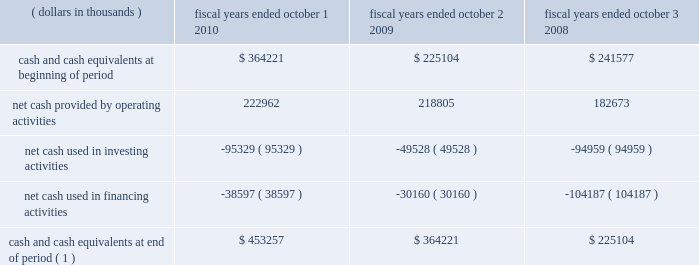31mar201122064257 positions which were required to be capitalized .
There are no positions which we anticipate could change materially within the next twelve months .
Liquidity and capital resources .
( 1 ) does not include restricted cash balances cash flow from operating activities : cash provided from operating activities is net income adjusted for certain non-cash items and changes in certain assets and liabilities .
For fiscal year 2010 we generated $ 223.0 million in cash flow from operations , an increase of $ 4.2 million when compared to the $ 218.8 million generated in fiscal year 2009 .
During fiscal year 2010 , net income increased by $ 42.3 million to $ 137.3 million when compared to fiscal year 2009 .
Despite the increase in net income , net cash provided by operating activities remained relatively consistent .
This was primarily due to : 2022 fiscal year 2010 net income included a deferred tax expense of $ 38.5 million compared to a $ 24.9 million deferred tax benefit included in 2009 net income due to the release of the tax valuation allowance in fiscal year 2009 .
2022 during fiscal year 2010 , the company invested in working capital as result of higher business activity .
Compared to fiscal year 2009 , accounts receivable , inventory and accounts payable increased by $ 60.9 million , $ 38.8 million and $ 42.9 million , respectively .
Cash flow from investing activities : cash flow from investing activities consists primarily of capital expenditures and acquisitions .
We had net cash outflows of $ 95.3 million in fiscal year 2010 , compared to $ 49.5 million in fiscal year 2009 .
The increase is primarily due to an increase of $ 49.8 million in capital expenditures .
We anticipate our capital spending to be consistent in fiscal year 2011 to maintain our projected growth rate .
Cash flow from financing activities : cash flows from financing activities consist primarily of cash transactions related to debt and equity .
During fiscal year 2010 , we had net cash outflows of $ 38.6 million , compared to $ 30.2 million in fiscal year 2009 .
During the year we had the following significant transactions : 2022 we retired $ 53.0 million in aggregate principal amount ( carrying value of $ 51.1 million ) of 2007 convertible notes for $ 80.7 million , which included a $ 29.6 million premium paid for the equity component of the instrument .
2022 we received net proceeds from employee stock option exercises of $ 40.5 million in fiscal year 2010 , compared to $ 38.7 million in fiscal year 2009 .
Skyworks / 2010 annual report 103 .
What is the percent increase in cash and cash equivalents from year 2009 to 2010? 
Computations: ((453257 - 364221) / 364221)
Answer: 0.24446. 31mar201122064257 positions which were required to be capitalized .
There are no positions which we anticipate could change materially within the next twelve months .
Liquidity and capital resources .
( 1 ) does not include restricted cash balances cash flow from operating activities : cash provided from operating activities is net income adjusted for certain non-cash items and changes in certain assets and liabilities .
For fiscal year 2010 we generated $ 223.0 million in cash flow from operations , an increase of $ 4.2 million when compared to the $ 218.8 million generated in fiscal year 2009 .
During fiscal year 2010 , net income increased by $ 42.3 million to $ 137.3 million when compared to fiscal year 2009 .
Despite the increase in net income , net cash provided by operating activities remained relatively consistent .
This was primarily due to : 2022 fiscal year 2010 net income included a deferred tax expense of $ 38.5 million compared to a $ 24.9 million deferred tax benefit included in 2009 net income due to the release of the tax valuation allowance in fiscal year 2009 .
2022 during fiscal year 2010 , the company invested in working capital as result of higher business activity .
Compared to fiscal year 2009 , accounts receivable , inventory and accounts payable increased by $ 60.9 million , $ 38.8 million and $ 42.9 million , respectively .
Cash flow from investing activities : cash flow from investing activities consists primarily of capital expenditures and acquisitions .
We had net cash outflows of $ 95.3 million in fiscal year 2010 , compared to $ 49.5 million in fiscal year 2009 .
The increase is primarily due to an increase of $ 49.8 million in capital expenditures .
We anticipate our capital spending to be consistent in fiscal year 2011 to maintain our projected growth rate .
Cash flow from financing activities : cash flows from financing activities consist primarily of cash transactions related to debt and equity .
During fiscal year 2010 , we had net cash outflows of $ 38.6 million , compared to $ 30.2 million in fiscal year 2009 .
During the year we had the following significant transactions : 2022 we retired $ 53.0 million in aggregate principal amount ( carrying value of $ 51.1 million ) of 2007 convertible notes for $ 80.7 million , which included a $ 29.6 million premium paid for the equity component of the instrument .
2022 we received net proceeds from employee stock option exercises of $ 40.5 million in fiscal year 2010 , compared to $ 38.7 million in fiscal year 2009 .
Skyworks / 2010 annual report 103 .
In 2009 what was the percentage change in the liquidity and capital resources? 
Computations: ((364221 - 225104) / 225104)
Answer: 0.61801. 31mar201122064257 positions which were required to be capitalized .
There are no positions which we anticipate could change materially within the next twelve months .
Liquidity and capital resources .
( 1 ) does not include restricted cash balances cash flow from operating activities : cash provided from operating activities is net income adjusted for certain non-cash items and changes in certain assets and liabilities .
For fiscal year 2010 we generated $ 223.0 million in cash flow from operations , an increase of $ 4.2 million when compared to the $ 218.8 million generated in fiscal year 2009 .
During fiscal year 2010 , net income increased by $ 42.3 million to $ 137.3 million when compared to fiscal year 2009 .
Despite the increase in net income , net cash provided by operating activities remained relatively consistent .
This was primarily due to : 2022 fiscal year 2010 net income included a deferred tax expense of $ 38.5 million compared to a $ 24.9 million deferred tax benefit included in 2009 net income due to the release of the tax valuation allowance in fiscal year 2009 .
2022 during fiscal year 2010 , the company invested in working capital as result of higher business activity .
Compared to fiscal year 2009 , accounts receivable , inventory and accounts payable increased by $ 60.9 million , $ 38.8 million and $ 42.9 million , respectively .
Cash flow from investing activities : cash flow from investing activities consists primarily of capital expenditures and acquisitions .
We had net cash outflows of $ 95.3 million in fiscal year 2010 , compared to $ 49.5 million in fiscal year 2009 .
The increase is primarily due to an increase of $ 49.8 million in capital expenditures .
We anticipate our capital spending to be consistent in fiscal year 2011 to maintain our projected growth rate .
Cash flow from financing activities : cash flows from financing activities consist primarily of cash transactions related to debt and equity .
During fiscal year 2010 , we had net cash outflows of $ 38.6 million , compared to $ 30.2 million in fiscal year 2009 .
During the year we had the following significant transactions : 2022 we retired $ 53.0 million in aggregate principal amount ( carrying value of $ 51.1 million ) of 2007 convertible notes for $ 80.7 million , which included a $ 29.6 million premium paid for the equity component of the instrument .
2022 we received net proceeds from employee stock option exercises of $ 40.5 million in fiscal year 2010 , compared to $ 38.7 million in fiscal year 2009 .
Skyworks / 2010 annual report 103 .
What is the percentage change in cash flow from operations from fiscal year 2009 to fiscal year 2010 , ( in millions ) ? 
Computations: (4.2 - 218.8)
Answer: -214.6. 